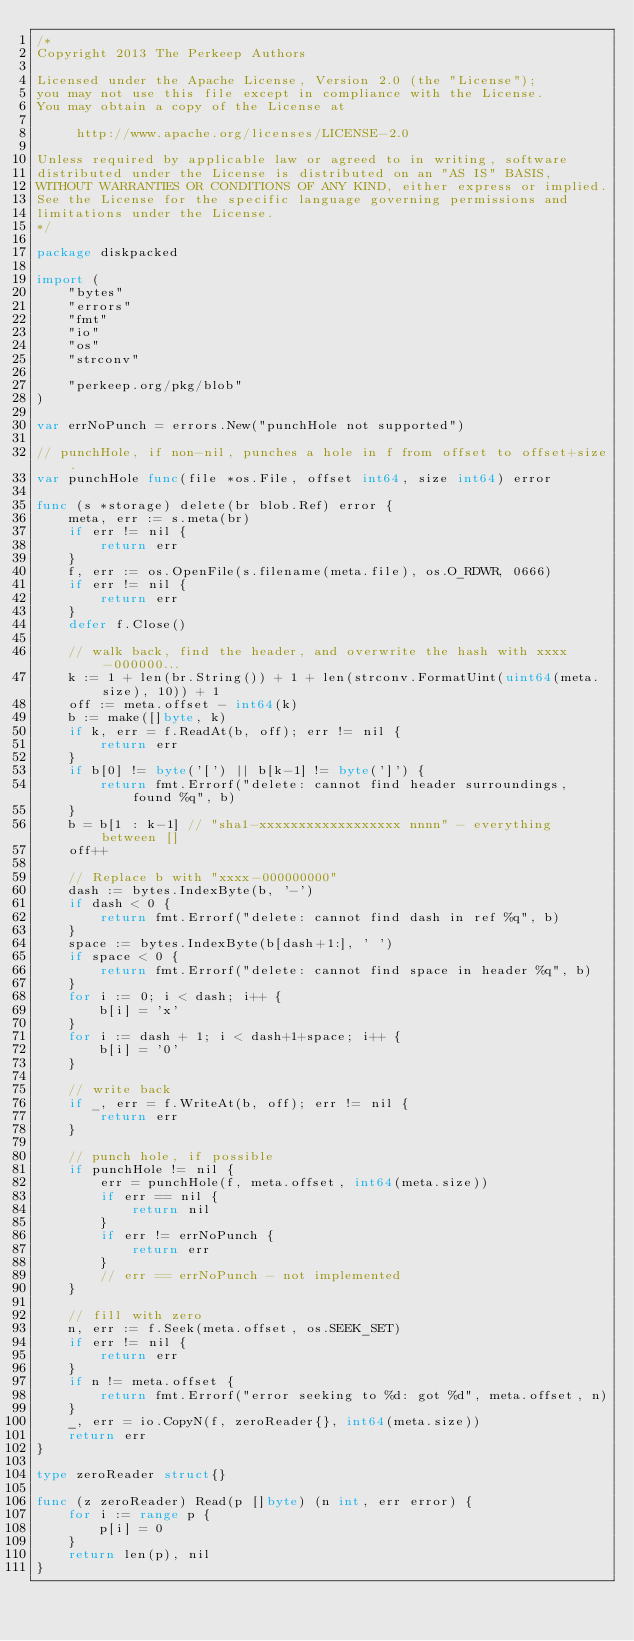Convert code to text. <code><loc_0><loc_0><loc_500><loc_500><_Go_>/*
Copyright 2013 The Perkeep Authors

Licensed under the Apache License, Version 2.0 (the "License");
you may not use this file except in compliance with the License.
You may obtain a copy of the License at

     http://www.apache.org/licenses/LICENSE-2.0

Unless required by applicable law or agreed to in writing, software
distributed under the License is distributed on an "AS IS" BASIS,
WITHOUT WARRANTIES OR CONDITIONS OF ANY KIND, either express or implied.
See the License for the specific language governing permissions and
limitations under the License.
*/

package diskpacked

import (
	"bytes"
	"errors"
	"fmt"
	"io"
	"os"
	"strconv"

	"perkeep.org/pkg/blob"
)

var errNoPunch = errors.New("punchHole not supported")

// punchHole, if non-nil, punches a hole in f from offset to offset+size.
var punchHole func(file *os.File, offset int64, size int64) error

func (s *storage) delete(br blob.Ref) error {
	meta, err := s.meta(br)
	if err != nil {
		return err
	}
	f, err := os.OpenFile(s.filename(meta.file), os.O_RDWR, 0666)
	if err != nil {
		return err
	}
	defer f.Close()

	// walk back, find the header, and overwrite the hash with xxxx-000000...
	k := 1 + len(br.String()) + 1 + len(strconv.FormatUint(uint64(meta.size), 10)) + 1
	off := meta.offset - int64(k)
	b := make([]byte, k)
	if k, err = f.ReadAt(b, off); err != nil {
		return err
	}
	if b[0] != byte('[') || b[k-1] != byte(']') {
		return fmt.Errorf("delete: cannot find header surroundings, found %q", b)
	}
	b = b[1 : k-1] // "sha1-xxxxxxxxxxxxxxxxxx nnnn" - everything between []
	off++

	// Replace b with "xxxx-000000000"
	dash := bytes.IndexByte(b, '-')
	if dash < 0 {
		return fmt.Errorf("delete: cannot find dash in ref %q", b)
	}
	space := bytes.IndexByte(b[dash+1:], ' ')
	if space < 0 {
		return fmt.Errorf("delete: cannot find space in header %q", b)
	}
	for i := 0; i < dash; i++ {
		b[i] = 'x'
	}
	for i := dash + 1; i < dash+1+space; i++ {
		b[i] = '0'
	}

	// write back
	if _, err = f.WriteAt(b, off); err != nil {
		return err
	}

	// punch hole, if possible
	if punchHole != nil {
		err = punchHole(f, meta.offset, int64(meta.size))
		if err == nil {
			return nil
		}
		if err != errNoPunch {
			return err
		}
		// err == errNoPunch - not implemented
	}

	// fill with zero
	n, err := f.Seek(meta.offset, os.SEEK_SET)
	if err != nil {
		return err
	}
	if n != meta.offset {
		return fmt.Errorf("error seeking to %d: got %d", meta.offset, n)
	}
	_, err = io.CopyN(f, zeroReader{}, int64(meta.size))
	return err
}

type zeroReader struct{}

func (z zeroReader) Read(p []byte) (n int, err error) {
	for i := range p {
		p[i] = 0
	}
	return len(p), nil
}
</code> 